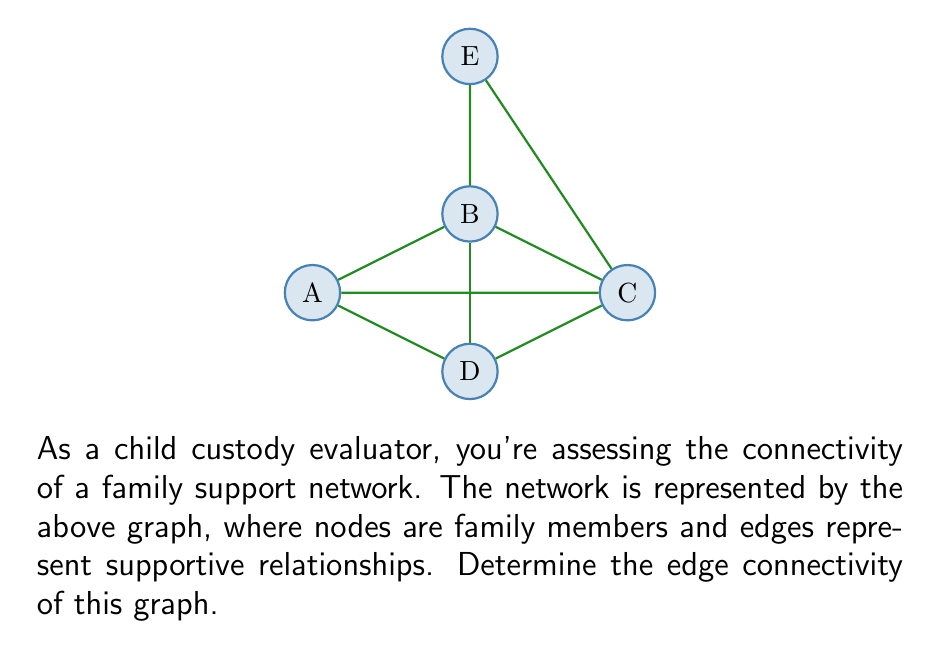Give your solution to this math problem. To determine the edge connectivity of this graph, we need to find the minimum number of edges that, when removed, would disconnect the graph. Let's approach this step-by-step:

1) First, let's count the total number of vertices and edges:
   - Vertices: 5 (A, B, C, D, E)
   - Edges: 8

2) Now, let's examine the possible ways to disconnect the graph:

   a) Removing edges connected to E:
      - If we remove edges BE and CE, E becomes isolated.
      This requires removing 2 edges.

   b) Removing edges to separate A or D from the rest:
      - For A: We need to remove AB, AC, and AD (3 edges).
      - For D: We need to remove AD, BD, and CD (3 edges).

   c) Removing edges to separate B or C from the rest:
      - For B: We need to remove at least 3 edges (e.g., AB, BD, BE).
      - For C: We need to remove at least 3 edges (e.g., AC, CD, CE).

3) The minimum number of edges we need to remove to disconnect the graph is 2, which occurs when we isolate vertex E.

4) Therefore, the edge connectivity of this graph is 2.

In the context of family support systems, this means that the network is most vulnerable at the connection points to member E. Removing support from E (by severing its connections to B and C) would isolate E from the rest of the family support system.
Answer: 2 